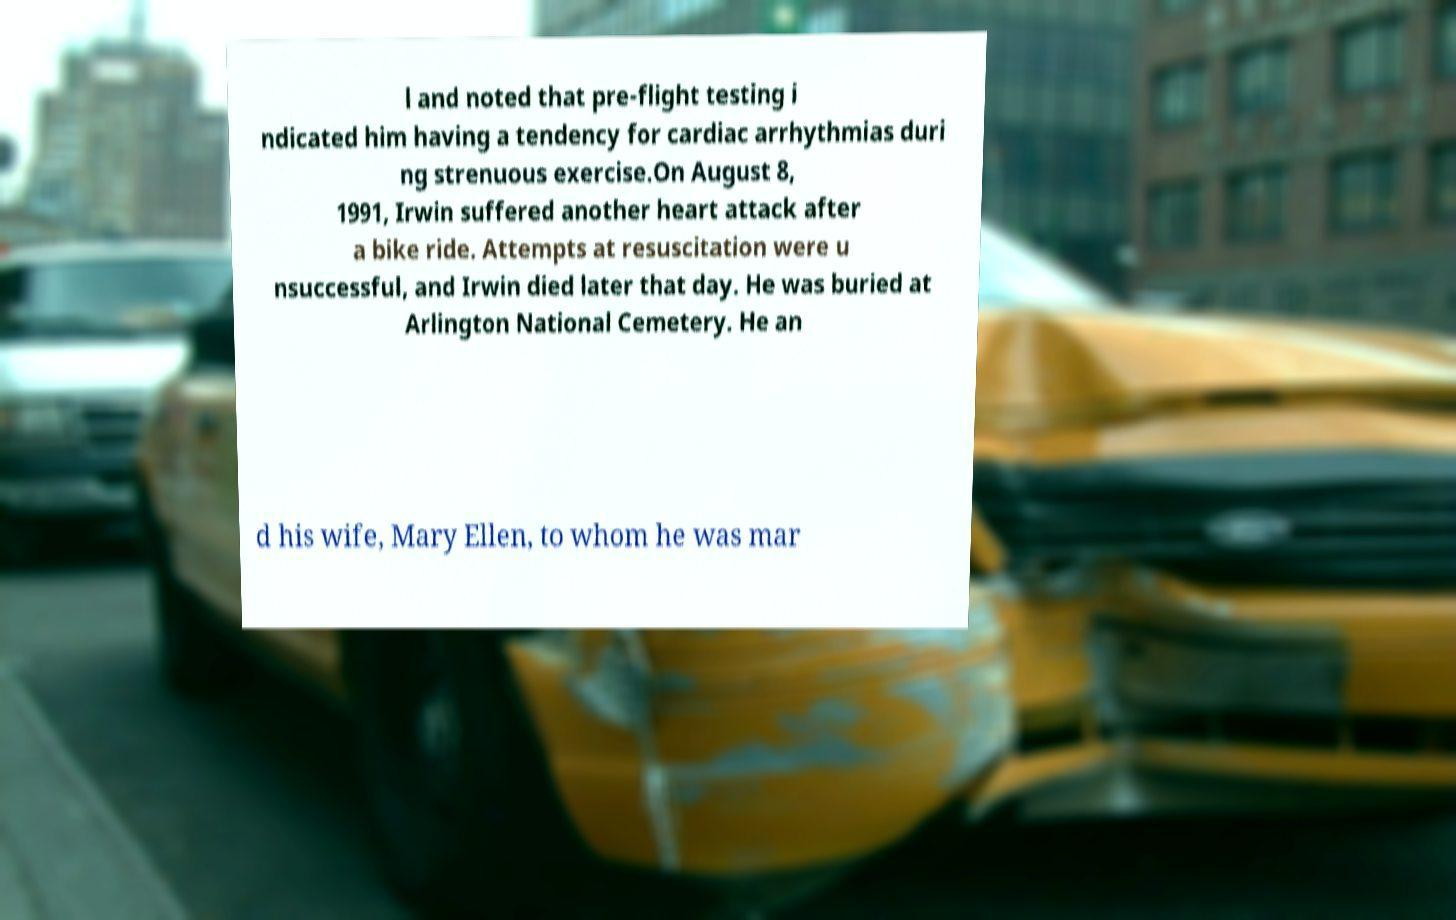Please identify and transcribe the text found in this image. l and noted that pre-flight testing i ndicated him having a tendency for cardiac arrhythmias duri ng strenuous exercise.On August 8, 1991, Irwin suffered another heart attack after a bike ride. Attempts at resuscitation were u nsuccessful, and Irwin died later that day. He was buried at Arlington National Cemetery. He an d his wife, Mary Ellen, to whom he was mar 